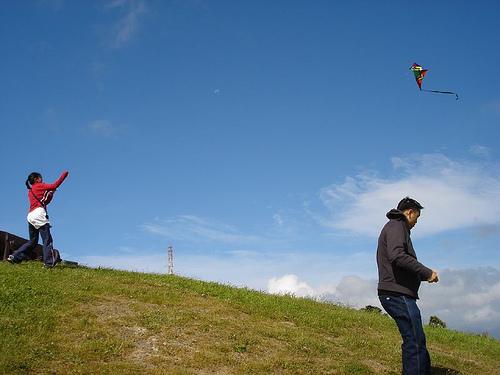Is she spending time with her dad?
Write a very short answer. Yes. Does the kite have a blue tail?
Answer briefly. No. What is in the sky?
Write a very short answer. Kite. Is the person in pink old enough to drive a car?
Write a very short answer. No. Are they fighting kites against each other?
Give a very brief answer. No. Will it rain?
Keep it brief. No. 